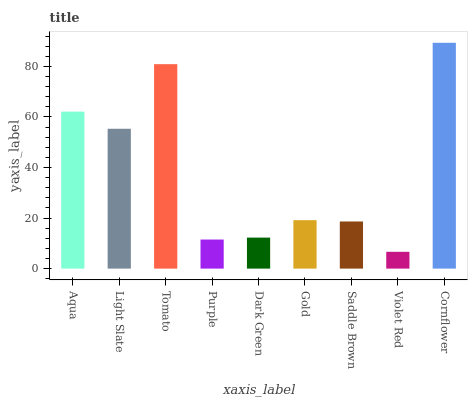Is Light Slate the minimum?
Answer yes or no. No. Is Light Slate the maximum?
Answer yes or no. No. Is Aqua greater than Light Slate?
Answer yes or no. Yes. Is Light Slate less than Aqua?
Answer yes or no. Yes. Is Light Slate greater than Aqua?
Answer yes or no. No. Is Aqua less than Light Slate?
Answer yes or no. No. Is Gold the high median?
Answer yes or no. Yes. Is Gold the low median?
Answer yes or no. Yes. Is Dark Green the high median?
Answer yes or no. No. Is Dark Green the low median?
Answer yes or no. No. 